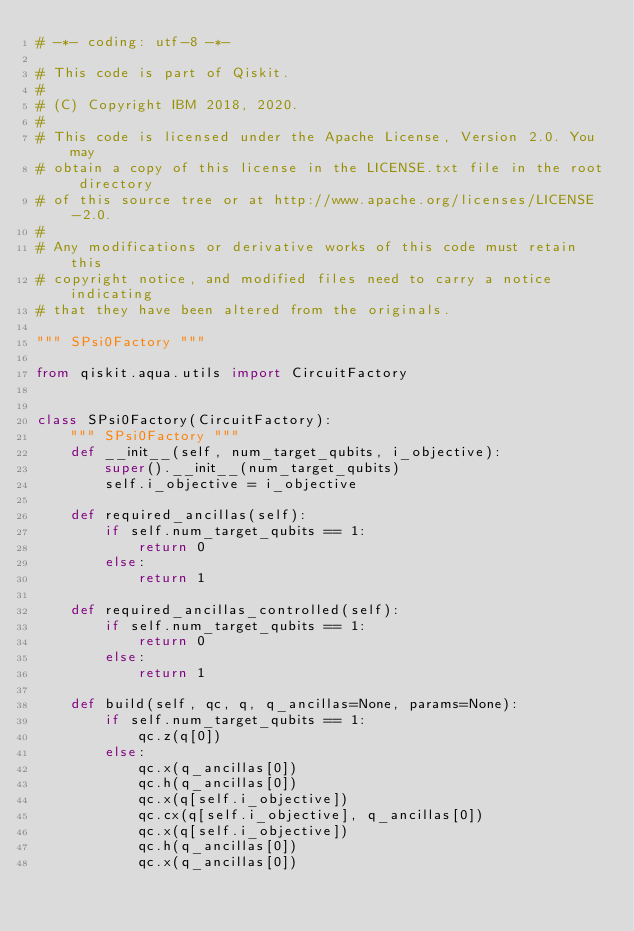Convert code to text. <code><loc_0><loc_0><loc_500><loc_500><_Python_># -*- coding: utf-8 -*-

# This code is part of Qiskit.
#
# (C) Copyright IBM 2018, 2020.
#
# This code is licensed under the Apache License, Version 2.0. You may
# obtain a copy of this license in the LICENSE.txt file in the root directory
# of this source tree or at http://www.apache.org/licenses/LICENSE-2.0.
#
# Any modifications or derivative works of this code must retain this
# copyright notice, and modified files need to carry a notice indicating
# that they have been altered from the originals.

""" SPsi0Factory """

from qiskit.aqua.utils import CircuitFactory


class SPsi0Factory(CircuitFactory):
    """ SPsi0Factory """
    def __init__(self, num_target_qubits, i_objective):
        super().__init__(num_target_qubits)
        self.i_objective = i_objective

    def required_ancillas(self):
        if self.num_target_qubits == 1:
            return 0
        else:
            return 1

    def required_ancillas_controlled(self):
        if self.num_target_qubits == 1:
            return 0
        else:
            return 1

    def build(self, qc, q, q_ancillas=None, params=None):
        if self.num_target_qubits == 1:
            qc.z(q[0])
        else:
            qc.x(q_ancillas[0])
            qc.h(q_ancillas[0])
            qc.x(q[self.i_objective])
            qc.cx(q[self.i_objective], q_ancillas[0])
            qc.x(q[self.i_objective])
            qc.h(q_ancillas[0])
            qc.x(q_ancillas[0])
</code> 